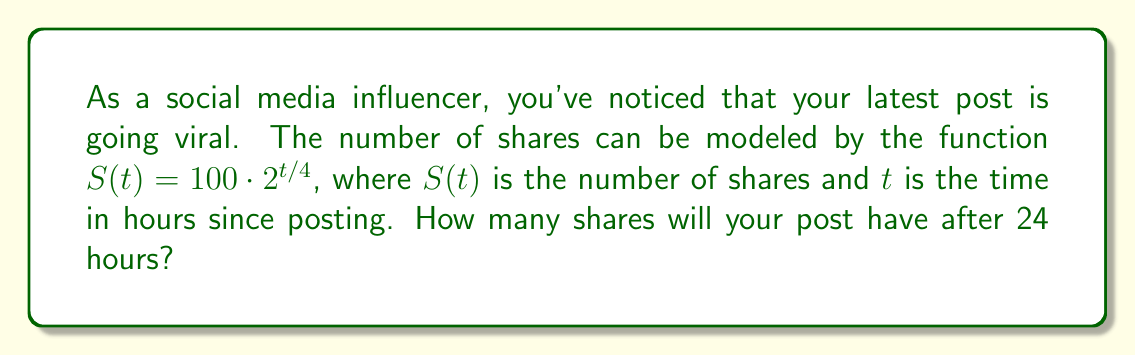Teach me how to tackle this problem. To solve this problem, we'll follow these steps:

1) We're given the function $S(t) = 100 \cdot 2^{t/4}$, where:
   - $S(t)$ is the number of shares
   - $t$ is the time in hours
   - 100 is the initial number of shares
   - $2^{t/4}$ represents the exponential growth

2) We need to find $S(24)$, i.e., the number of shares after 24 hours.

3) Let's substitute $t = 24$ into the function:

   $S(24) = 100 \cdot 2^{24/4}$

4) Simplify the exponent:
   
   $S(24) = 100 \cdot 2^6$

5) Calculate $2^6$:
   
   $2^6 = 64$

6) Multiply:
   
   $S(24) = 100 \cdot 64 = 6400$

Therefore, after 24 hours, your post will have 6400 shares.
Answer: 6400 shares 